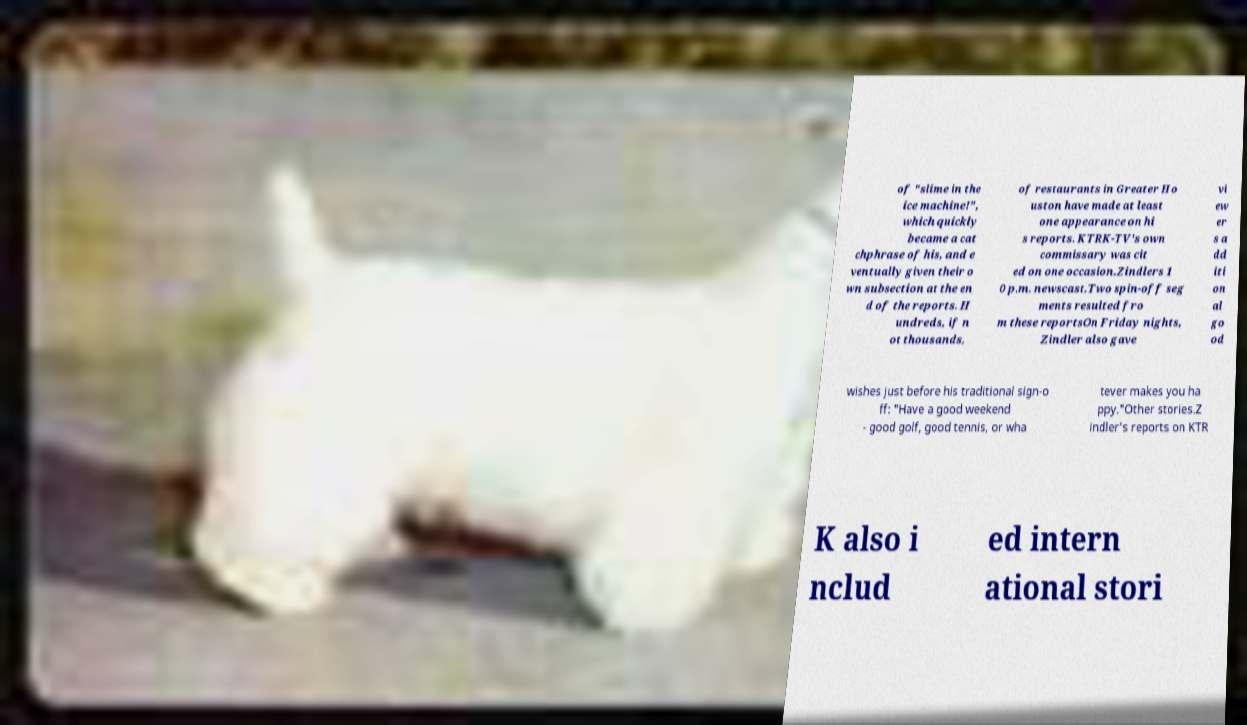There's text embedded in this image that I need extracted. Can you transcribe it verbatim? of "slime in the ice machine!", which quickly became a cat chphrase of his, and e ventually given their o wn subsection at the en d of the reports. H undreds, if n ot thousands, of restaurants in Greater Ho uston have made at least one appearance on hi s reports. KTRK-TV's own commissary was cit ed on one occasion.Zindlers 1 0 p.m. newscast.Two spin-off seg ments resulted fro m these reportsOn Friday nights, Zindler also gave vi ew er s a dd iti on al go od wishes just before his traditional sign-o ff: "Have a good weekend - good golf, good tennis, or wha tever makes you ha ppy."Other stories.Z indler's reports on KTR K also i nclud ed intern ational stori 